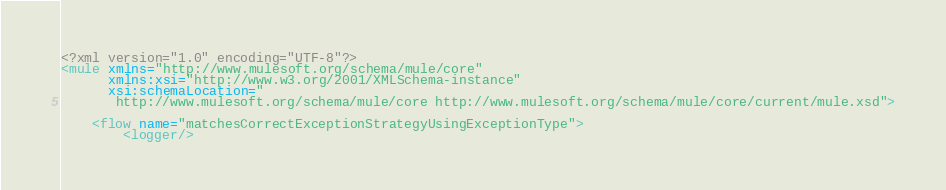<code> <loc_0><loc_0><loc_500><loc_500><_XML_><?xml version="1.0" encoding="UTF-8"?>
<mule xmlns="http://www.mulesoft.org/schema/mule/core"
      xmlns:xsi="http://www.w3.org/2001/XMLSchema-instance"
      xsi:schemaLocation="
       http://www.mulesoft.org/schema/mule/core http://www.mulesoft.org/schema/mule/core/current/mule.xsd">

    <flow name="matchesCorrectExceptionStrategyUsingExceptionType">
        <logger/></code> 